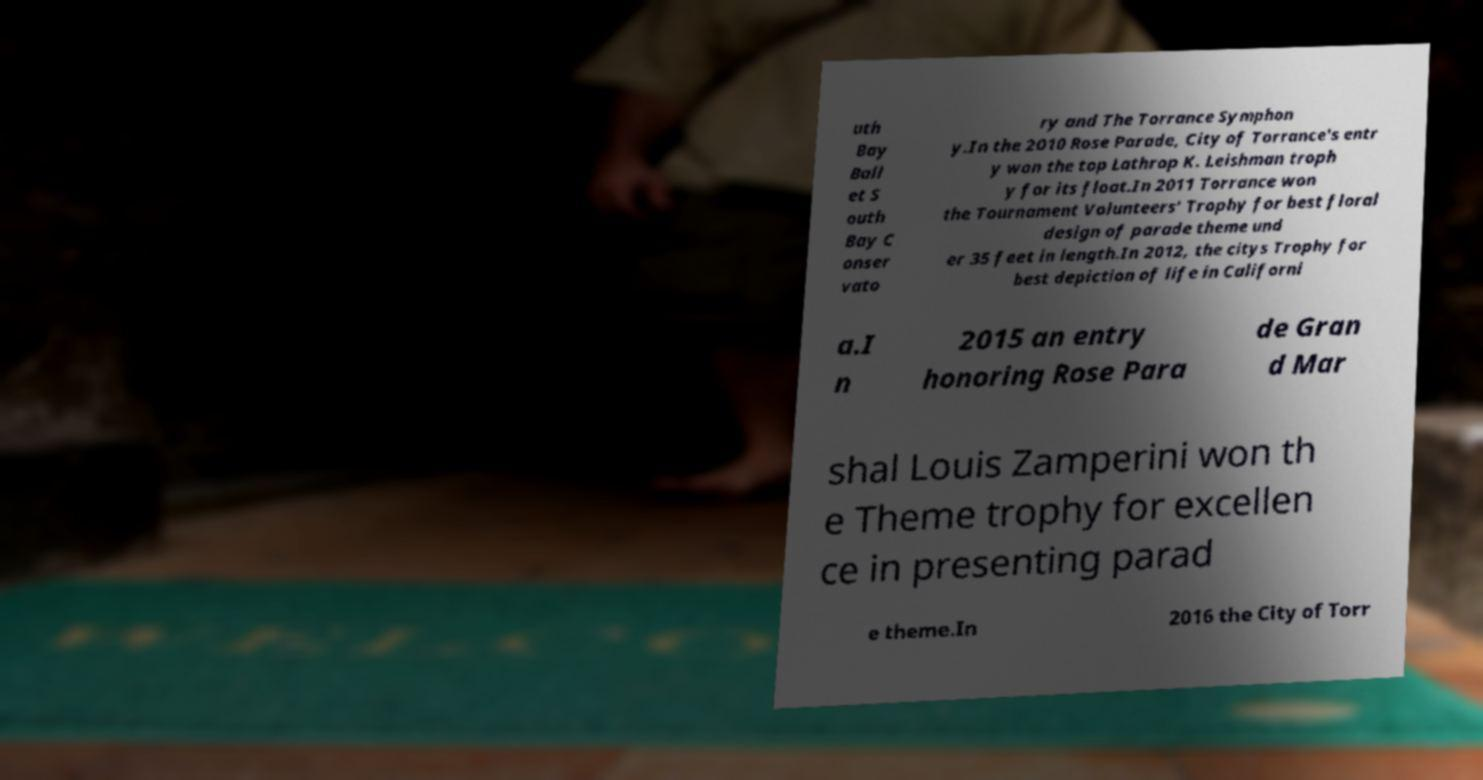What messages or text are displayed in this image? I need them in a readable, typed format. uth Bay Ball et S outh Bay C onser vato ry and The Torrance Symphon y.In the 2010 Rose Parade, City of Torrance's entr y won the top Lathrop K. Leishman troph y for its float.In 2011 Torrance won the Tournament Volunteers' Trophy for best floral design of parade theme und er 35 feet in length.In 2012, the citys Trophy for best depiction of life in Californi a.I n 2015 an entry honoring Rose Para de Gran d Mar shal Louis Zamperini won th e Theme trophy for excellen ce in presenting parad e theme.In 2016 the City of Torr 